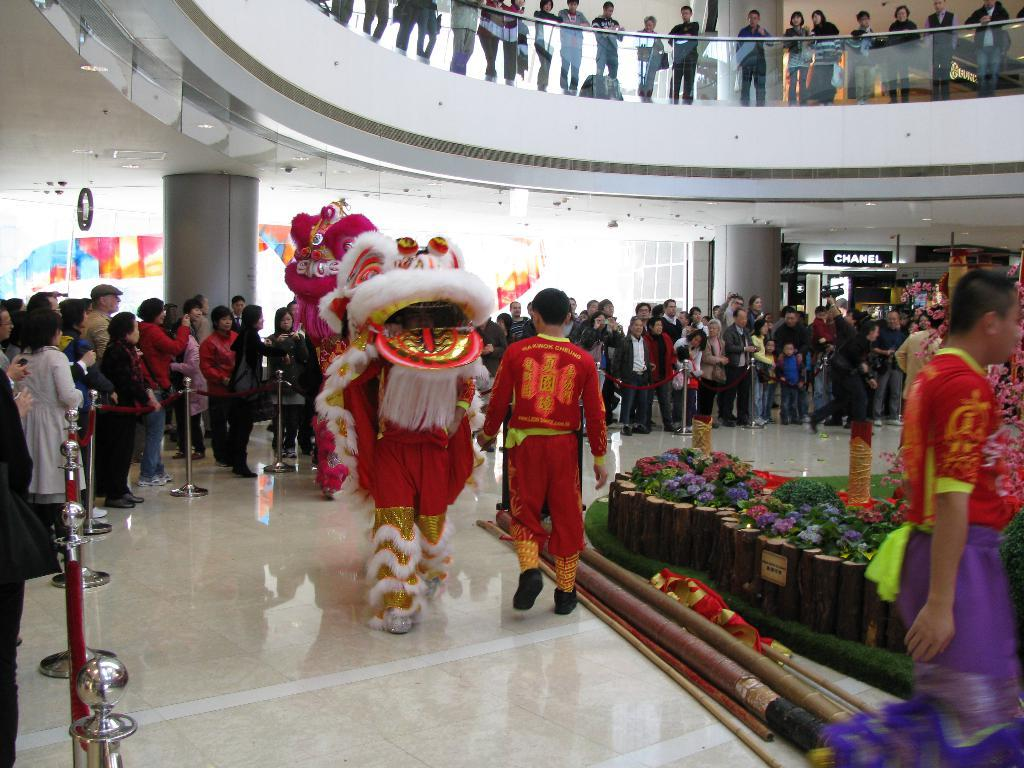What is the main subject of the image? The main subject of the image is a crowd. Where is the crowd located in the image? The crowd is standing on the floor. What can be seen on the left side of the image? There is a decoration on the left side of the image. How many pigs are visible in the image? There are no pigs present in the image. What type of polish is being applied to the rabbit in the image? There is no rabbit or polish present in the image. 